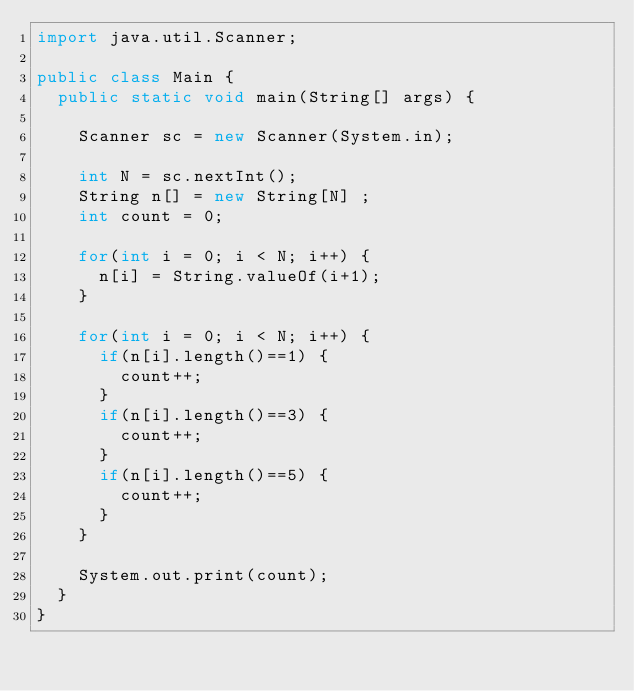<code> <loc_0><loc_0><loc_500><loc_500><_Java_>import java.util.Scanner;

public class Main {
	public static void main(String[] args) {

		Scanner sc = new Scanner(System.in);

		int N = sc.nextInt();
		String n[] = new String[N] ;
		int count = 0;

		for(int i = 0; i < N; i++) {
			n[i] = String.valueOf(i+1);
		}
		
		for(int i = 0; i < N; i++) {
			if(n[i].length()==1) {
				count++;
			}
			if(n[i].length()==3) {
				count++;
			}
			if(n[i].length()==5) {
				count++;
			}
		}
		
		System.out.print(count);
	}
}</code> 